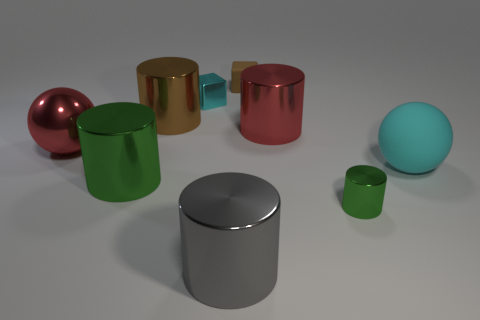Add 1 cyan cubes. How many objects exist? 10 Subtract all big red cylinders. How many cylinders are left? 4 Subtract all cylinders. How many objects are left? 4 Subtract 5 cylinders. How many cylinders are left? 0 Subtract 0 gray balls. How many objects are left? 9 Subtract all green balls. Subtract all blue blocks. How many balls are left? 2 Subtract all green spheres. How many red cylinders are left? 1 Subtract all purple objects. Subtract all large gray shiny cylinders. How many objects are left? 8 Add 2 big matte spheres. How many big matte spheres are left? 3 Add 6 big gray matte things. How many big gray matte things exist? 6 